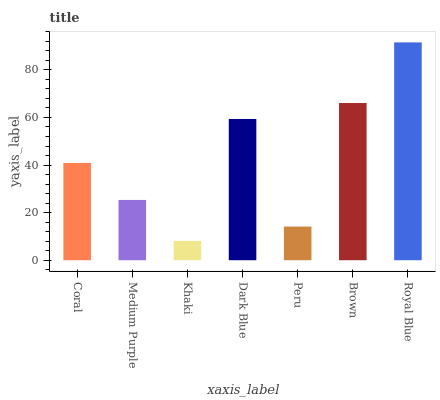Is Khaki the minimum?
Answer yes or no. Yes. Is Royal Blue the maximum?
Answer yes or no. Yes. Is Medium Purple the minimum?
Answer yes or no. No. Is Medium Purple the maximum?
Answer yes or no. No. Is Coral greater than Medium Purple?
Answer yes or no. Yes. Is Medium Purple less than Coral?
Answer yes or no. Yes. Is Medium Purple greater than Coral?
Answer yes or no. No. Is Coral less than Medium Purple?
Answer yes or no. No. Is Coral the high median?
Answer yes or no. Yes. Is Coral the low median?
Answer yes or no. Yes. Is Dark Blue the high median?
Answer yes or no. No. Is Brown the low median?
Answer yes or no. No. 